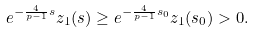Convert formula to latex. <formula><loc_0><loc_0><loc_500><loc_500>e ^ { - \frac { 4 } { p - 1 } s } z _ { 1 } ( s ) \geq e ^ { - \frac { 4 } { p - 1 } s _ { 0 } } z _ { 1 } ( s _ { 0 } ) > 0 .</formula> 